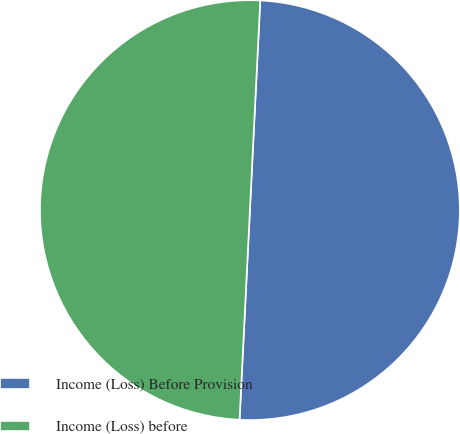<chart> <loc_0><loc_0><loc_500><loc_500><pie_chart><fcel>Income (Loss) Before Provision<fcel>Income (Loss) before<nl><fcel>50.0%<fcel>50.0%<nl></chart> 